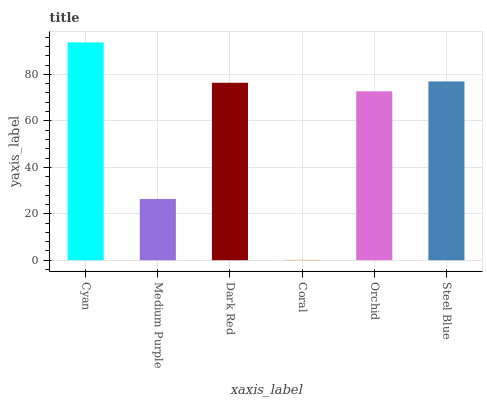Is Coral the minimum?
Answer yes or no. Yes. Is Cyan the maximum?
Answer yes or no. Yes. Is Medium Purple the minimum?
Answer yes or no. No. Is Medium Purple the maximum?
Answer yes or no. No. Is Cyan greater than Medium Purple?
Answer yes or no. Yes. Is Medium Purple less than Cyan?
Answer yes or no. Yes. Is Medium Purple greater than Cyan?
Answer yes or no. No. Is Cyan less than Medium Purple?
Answer yes or no. No. Is Dark Red the high median?
Answer yes or no. Yes. Is Orchid the low median?
Answer yes or no. Yes. Is Coral the high median?
Answer yes or no. No. Is Coral the low median?
Answer yes or no. No. 